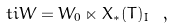<formula> <loc_0><loc_0><loc_500><loc_500>\ t i W = W _ { 0 } \ltimes X _ { * } ( T ) _ { I } \ ,</formula> 